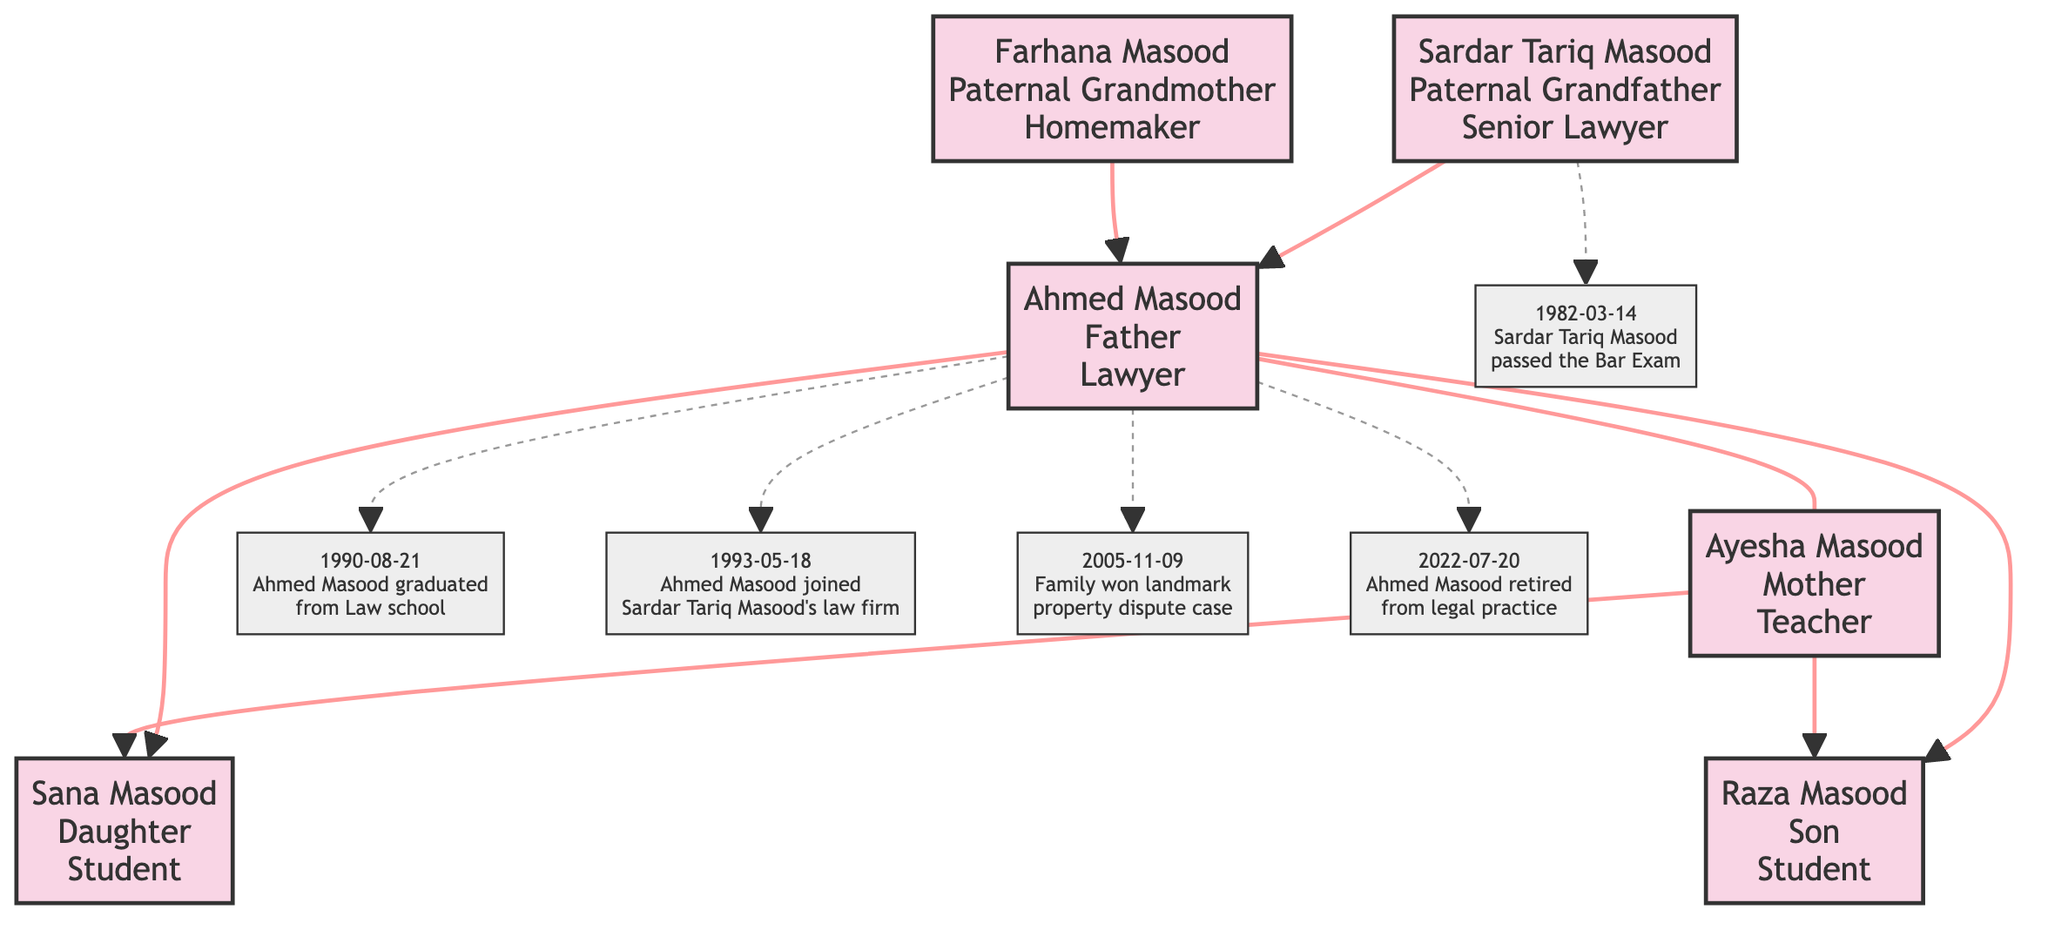What is the profession of Sardar Tariq Masood? The diagram indicates that Sardar Tariq Masood's profession is labeled as "Senior Lawyer." This information is located directly under his name in the node.
Answer: Senior Lawyer How many children does Ahmed Masood have? The diagram shows that Ahmed Masood has two children: Sana Masood and Raza Masood, represented by the arrows pointing from Ahmed's node to both of these child nodes.
Answer: 2 What relationship is indicated between Ahmed Masood and Ayesha Masood? The diagram shows a dashed line labeled "Spouse" connecting the nodes of Ahmed Masood and Ayesha Masood, indicating that they are married.
Answer: Spouse When did Sardar Tariq Masood pass the Bar Exam? The legal annotation in the diagram specifies that Sardar Tariq Masood passed the Bar Exam on March 14, 1982. This date is highlighted in the associated event node.
Answer: 1982-03-14 Who graduated from Law school in 1990? According to the event node in the diagram, the individual who graduated from Law school in 1990 is Ahmed Masood, as indicated by the corresponding date and description in the diagram.
Answer: Ahmed Masood Which family member retired from legal practice in 2022? The diagram indicates that Ahmed Masood retired from legal practice on July 20, 2022, as noted in the key event section connected to his node.
Answer: Ahmed Masood What is the profession of Raza Masood? The node corresponding to Raza Masood in the diagram lists his profession as "Student." This is detailed within his specific node.
Answer: Student How many total nodes are there in the family tree? Counting all the nodes from the diagram: there are 6 nodes representing family members along with their roles and professions.
Answer: 6 What significant event occurred on November 9, 2005? The diagram lists a key event indicating that the family won a landmark property dispute case on November 9, 2005. This information is found in the corresponding event node.
Answer: Family won landmark property dispute case 